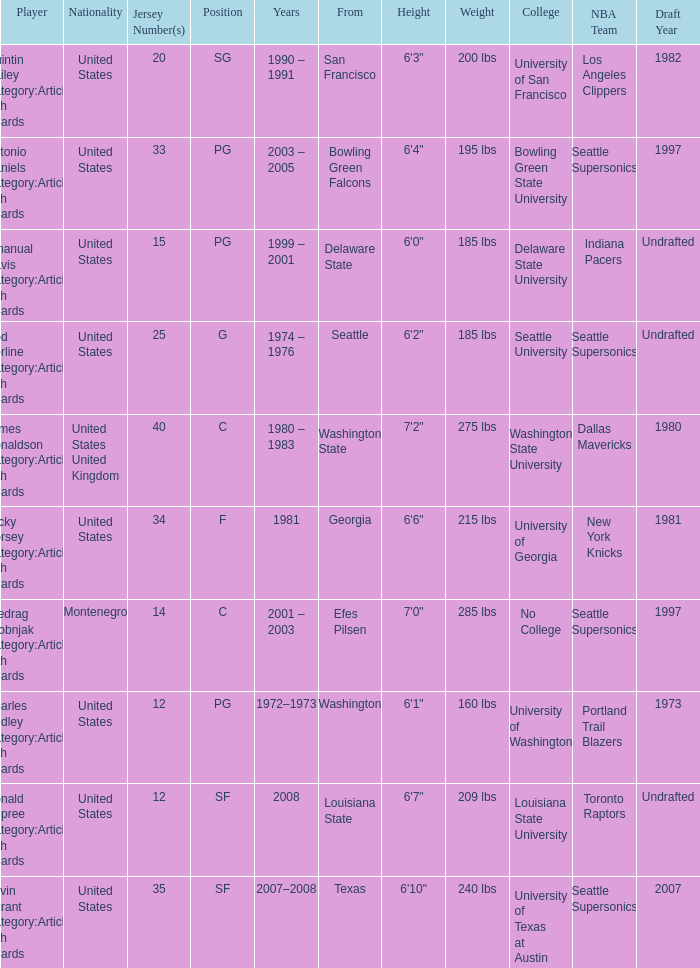What is the lowest jersey number of a player from louisiana state? 12.0. 